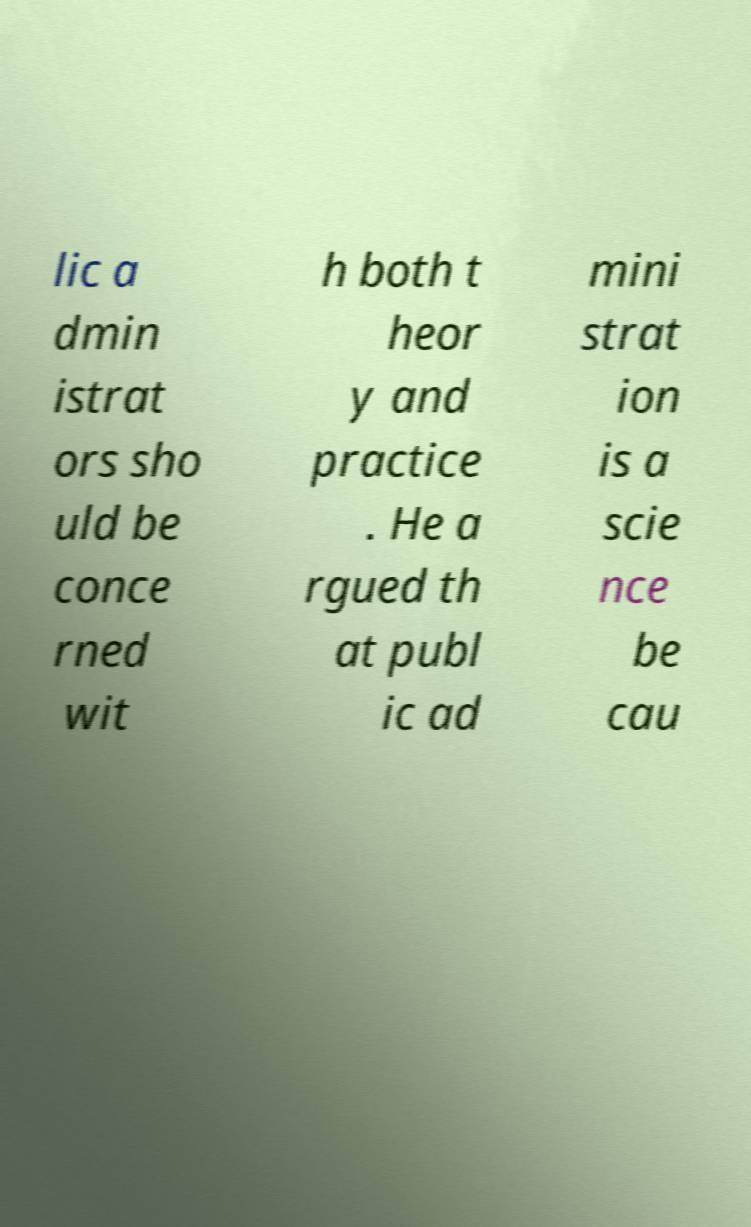Could you extract and type out the text from this image? lic a dmin istrat ors sho uld be conce rned wit h both t heor y and practice . He a rgued th at publ ic ad mini strat ion is a scie nce be cau 